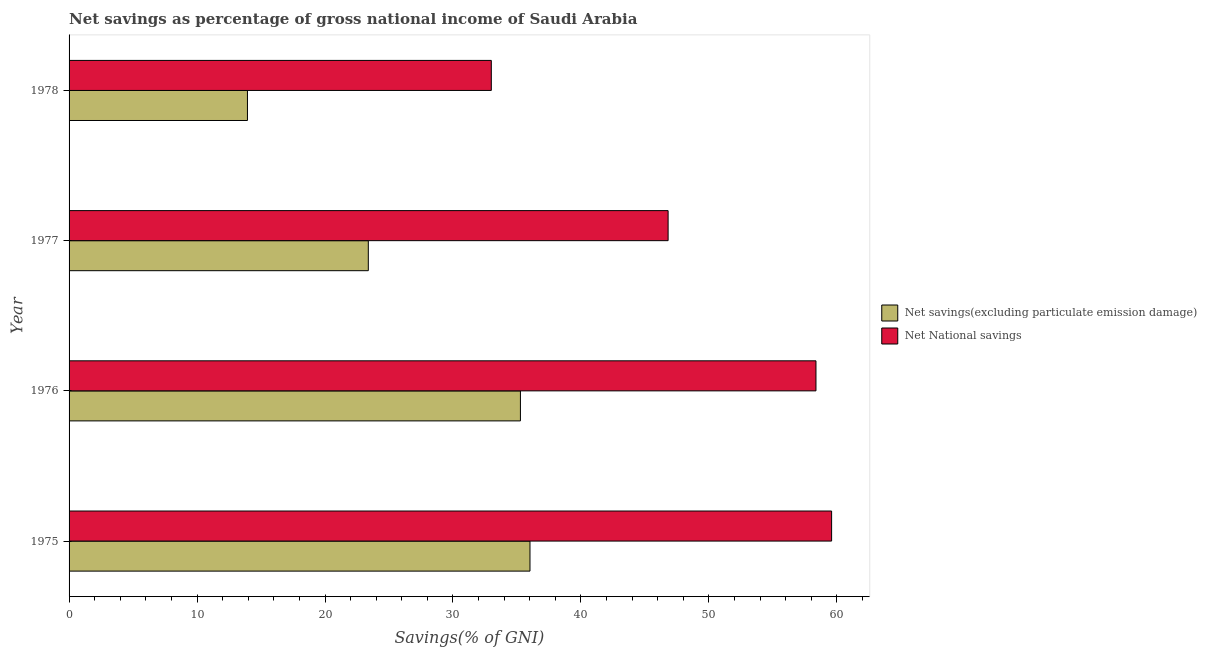How many bars are there on the 1st tick from the top?
Give a very brief answer. 2. What is the label of the 1st group of bars from the top?
Ensure brevity in your answer.  1978. What is the net savings(excluding particulate emission damage) in 1976?
Keep it short and to the point. 35.27. Across all years, what is the maximum net savings(excluding particulate emission damage)?
Your response must be concise. 36.02. Across all years, what is the minimum net national savings?
Offer a very short reply. 33. In which year was the net savings(excluding particulate emission damage) maximum?
Offer a very short reply. 1975. In which year was the net savings(excluding particulate emission damage) minimum?
Offer a very short reply. 1978. What is the total net national savings in the graph?
Your answer should be compact. 197.77. What is the difference between the net national savings in 1977 and that in 1978?
Offer a terse response. 13.82. What is the difference between the net savings(excluding particulate emission damage) in 1977 and the net national savings in 1978?
Make the answer very short. -9.61. What is the average net savings(excluding particulate emission damage) per year?
Make the answer very short. 27.15. In the year 1978, what is the difference between the net national savings and net savings(excluding particulate emission damage)?
Keep it short and to the point. 19.06. In how many years, is the net savings(excluding particulate emission damage) greater than 18 %?
Keep it short and to the point. 3. What is the ratio of the net national savings in 1977 to that in 1978?
Provide a succinct answer. 1.42. What is the difference between the highest and the second highest net savings(excluding particulate emission damage)?
Your answer should be very brief. 0.75. What is the difference between the highest and the lowest net national savings?
Provide a succinct answer. 26.59. In how many years, is the net national savings greater than the average net national savings taken over all years?
Keep it short and to the point. 2. What does the 2nd bar from the top in 1976 represents?
Make the answer very short. Net savings(excluding particulate emission damage). What does the 1st bar from the bottom in 1977 represents?
Make the answer very short. Net savings(excluding particulate emission damage). Are all the bars in the graph horizontal?
Your response must be concise. Yes. How many years are there in the graph?
Your answer should be very brief. 4. Are the values on the major ticks of X-axis written in scientific E-notation?
Provide a short and direct response. No. Does the graph contain any zero values?
Give a very brief answer. No. How are the legend labels stacked?
Your answer should be very brief. Vertical. What is the title of the graph?
Your answer should be very brief. Net savings as percentage of gross national income of Saudi Arabia. Does "Young" appear as one of the legend labels in the graph?
Offer a very short reply. No. What is the label or title of the X-axis?
Keep it short and to the point. Savings(% of GNI). What is the label or title of the Y-axis?
Make the answer very short. Year. What is the Savings(% of GNI) in Net savings(excluding particulate emission damage) in 1975?
Make the answer very short. 36.02. What is the Savings(% of GNI) of Net National savings in 1975?
Give a very brief answer. 59.59. What is the Savings(% of GNI) of Net savings(excluding particulate emission damage) in 1976?
Your answer should be compact. 35.27. What is the Savings(% of GNI) of Net National savings in 1976?
Keep it short and to the point. 58.37. What is the Savings(% of GNI) of Net savings(excluding particulate emission damage) in 1977?
Your response must be concise. 23.38. What is the Savings(% of GNI) in Net National savings in 1977?
Your answer should be very brief. 46.81. What is the Savings(% of GNI) of Net savings(excluding particulate emission damage) in 1978?
Make the answer very short. 13.94. What is the Savings(% of GNI) in Net National savings in 1978?
Keep it short and to the point. 33. Across all years, what is the maximum Savings(% of GNI) in Net savings(excluding particulate emission damage)?
Your response must be concise. 36.02. Across all years, what is the maximum Savings(% of GNI) of Net National savings?
Provide a short and direct response. 59.59. Across all years, what is the minimum Savings(% of GNI) in Net savings(excluding particulate emission damage)?
Your answer should be compact. 13.94. Across all years, what is the minimum Savings(% of GNI) of Net National savings?
Offer a very short reply. 33. What is the total Savings(% of GNI) in Net savings(excluding particulate emission damage) in the graph?
Give a very brief answer. 108.62. What is the total Savings(% of GNI) of Net National savings in the graph?
Keep it short and to the point. 197.77. What is the difference between the Savings(% of GNI) in Net savings(excluding particulate emission damage) in 1975 and that in 1976?
Provide a succinct answer. 0.75. What is the difference between the Savings(% of GNI) in Net National savings in 1975 and that in 1976?
Make the answer very short. 1.22. What is the difference between the Savings(% of GNI) in Net savings(excluding particulate emission damage) in 1975 and that in 1977?
Your answer should be very brief. 12.64. What is the difference between the Savings(% of GNI) in Net National savings in 1975 and that in 1977?
Provide a succinct answer. 12.78. What is the difference between the Savings(% of GNI) in Net savings(excluding particulate emission damage) in 1975 and that in 1978?
Make the answer very short. 22.08. What is the difference between the Savings(% of GNI) of Net National savings in 1975 and that in 1978?
Your answer should be compact. 26.59. What is the difference between the Savings(% of GNI) in Net savings(excluding particulate emission damage) in 1976 and that in 1977?
Ensure brevity in your answer.  11.89. What is the difference between the Savings(% of GNI) of Net National savings in 1976 and that in 1977?
Provide a short and direct response. 11.56. What is the difference between the Savings(% of GNI) of Net savings(excluding particulate emission damage) in 1976 and that in 1978?
Your answer should be very brief. 21.33. What is the difference between the Savings(% of GNI) of Net National savings in 1976 and that in 1978?
Make the answer very short. 25.37. What is the difference between the Savings(% of GNI) in Net savings(excluding particulate emission damage) in 1977 and that in 1978?
Offer a terse response. 9.44. What is the difference between the Savings(% of GNI) in Net National savings in 1977 and that in 1978?
Your response must be concise. 13.82. What is the difference between the Savings(% of GNI) in Net savings(excluding particulate emission damage) in 1975 and the Savings(% of GNI) in Net National savings in 1976?
Offer a very short reply. -22.35. What is the difference between the Savings(% of GNI) in Net savings(excluding particulate emission damage) in 1975 and the Savings(% of GNI) in Net National savings in 1977?
Keep it short and to the point. -10.79. What is the difference between the Savings(% of GNI) in Net savings(excluding particulate emission damage) in 1975 and the Savings(% of GNI) in Net National savings in 1978?
Make the answer very short. 3.02. What is the difference between the Savings(% of GNI) in Net savings(excluding particulate emission damage) in 1976 and the Savings(% of GNI) in Net National savings in 1977?
Provide a short and direct response. -11.54. What is the difference between the Savings(% of GNI) of Net savings(excluding particulate emission damage) in 1976 and the Savings(% of GNI) of Net National savings in 1978?
Provide a succinct answer. 2.27. What is the difference between the Savings(% of GNI) of Net savings(excluding particulate emission damage) in 1977 and the Savings(% of GNI) of Net National savings in 1978?
Keep it short and to the point. -9.61. What is the average Savings(% of GNI) in Net savings(excluding particulate emission damage) per year?
Keep it short and to the point. 27.15. What is the average Savings(% of GNI) in Net National savings per year?
Your answer should be very brief. 49.44. In the year 1975, what is the difference between the Savings(% of GNI) of Net savings(excluding particulate emission damage) and Savings(% of GNI) of Net National savings?
Keep it short and to the point. -23.57. In the year 1976, what is the difference between the Savings(% of GNI) of Net savings(excluding particulate emission damage) and Savings(% of GNI) of Net National savings?
Give a very brief answer. -23.1. In the year 1977, what is the difference between the Savings(% of GNI) in Net savings(excluding particulate emission damage) and Savings(% of GNI) in Net National savings?
Ensure brevity in your answer.  -23.43. In the year 1978, what is the difference between the Savings(% of GNI) in Net savings(excluding particulate emission damage) and Savings(% of GNI) in Net National savings?
Provide a short and direct response. -19.06. What is the ratio of the Savings(% of GNI) in Net savings(excluding particulate emission damage) in 1975 to that in 1976?
Your answer should be compact. 1.02. What is the ratio of the Savings(% of GNI) in Net National savings in 1975 to that in 1976?
Ensure brevity in your answer.  1.02. What is the ratio of the Savings(% of GNI) of Net savings(excluding particulate emission damage) in 1975 to that in 1977?
Give a very brief answer. 1.54. What is the ratio of the Savings(% of GNI) in Net National savings in 1975 to that in 1977?
Your answer should be compact. 1.27. What is the ratio of the Savings(% of GNI) of Net savings(excluding particulate emission damage) in 1975 to that in 1978?
Provide a succinct answer. 2.58. What is the ratio of the Savings(% of GNI) of Net National savings in 1975 to that in 1978?
Offer a very short reply. 1.81. What is the ratio of the Savings(% of GNI) in Net savings(excluding particulate emission damage) in 1976 to that in 1977?
Make the answer very short. 1.51. What is the ratio of the Savings(% of GNI) of Net National savings in 1976 to that in 1977?
Make the answer very short. 1.25. What is the ratio of the Savings(% of GNI) of Net savings(excluding particulate emission damage) in 1976 to that in 1978?
Provide a succinct answer. 2.53. What is the ratio of the Savings(% of GNI) of Net National savings in 1976 to that in 1978?
Ensure brevity in your answer.  1.77. What is the ratio of the Savings(% of GNI) in Net savings(excluding particulate emission damage) in 1977 to that in 1978?
Offer a terse response. 1.68. What is the ratio of the Savings(% of GNI) of Net National savings in 1977 to that in 1978?
Make the answer very short. 1.42. What is the difference between the highest and the second highest Savings(% of GNI) in Net savings(excluding particulate emission damage)?
Ensure brevity in your answer.  0.75. What is the difference between the highest and the second highest Savings(% of GNI) in Net National savings?
Your response must be concise. 1.22. What is the difference between the highest and the lowest Savings(% of GNI) of Net savings(excluding particulate emission damage)?
Give a very brief answer. 22.08. What is the difference between the highest and the lowest Savings(% of GNI) of Net National savings?
Give a very brief answer. 26.59. 